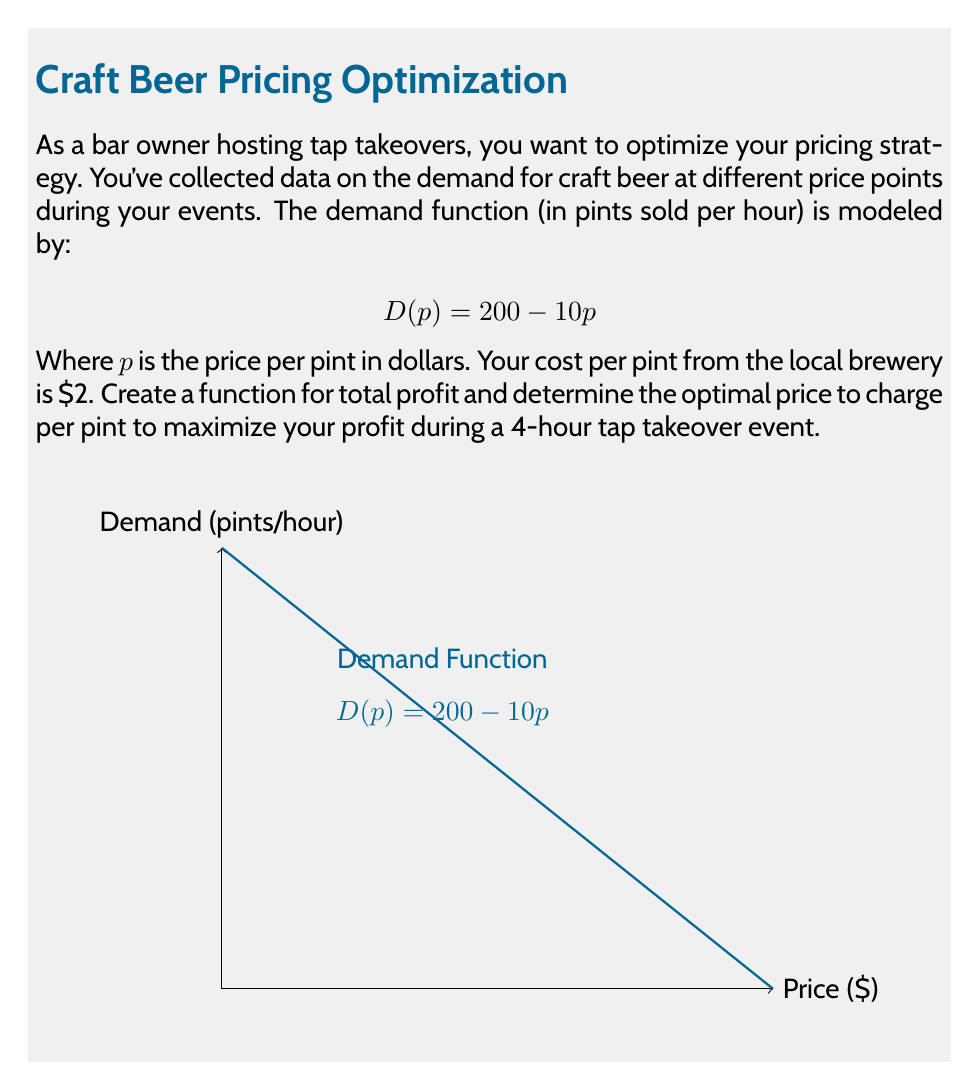Can you solve this math problem? Let's approach this step-by-step:

1) First, we need to create a profit function. Profit is calculated as revenue minus cost.

2) Revenue is price times quantity: $R = p \cdot D(p)$

3) Quantity is given by the demand function: $D(p) = 200 - 10p$

4) So, revenue function is: $R(p) = p(200 - 10p) = 200p - 10p^2$

5) Cost is $2 per pint, so total cost is: $C(p) = 2(200 - 10p) = 400 - 20p$

6) Profit function for one hour is revenue minus cost:
   $P(p) = R(p) - C(p) = (200p - 10p^2) - (400 - 20p) = 220p - 10p^2 - 400$

7) For a 4-hour event, we multiply this by 4:
   $P(p) = 4(220p - 10p^2 - 400) = 880p - 40p^2 - 1600$

8) To find the maximum profit, we differentiate and set to zero:
   $\frac{dP}{dp} = 880 - 80p = 0$

9) Solving this:
   $880 - 80p = 0$
   $880 = 80p$
   $p = 11$

10) The second derivative is negative ($-80$), confirming this is a maximum.

11) Therefore, the optimal price is $11 per pint.
Answer: $11 per pint 